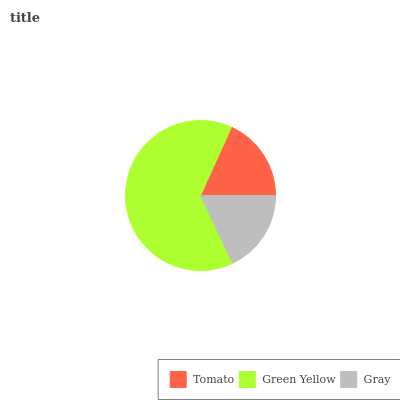Is Gray the minimum?
Answer yes or no. Yes. Is Green Yellow the maximum?
Answer yes or no. Yes. Is Green Yellow the minimum?
Answer yes or no. No. Is Gray the maximum?
Answer yes or no. No. Is Green Yellow greater than Gray?
Answer yes or no. Yes. Is Gray less than Green Yellow?
Answer yes or no. Yes. Is Gray greater than Green Yellow?
Answer yes or no. No. Is Green Yellow less than Gray?
Answer yes or no. No. Is Tomato the high median?
Answer yes or no. Yes. Is Tomato the low median?
Answer yes or no. Yes. Is Gray the high median?
Answer yes or no. No. Is Gray the low median?
Answer yes or no. No. 